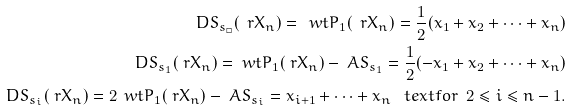<formula> <loc_0><loc_0><loc_500><loc_500>\ D S _ { s _ { \Box } } ( \ r X _ { n } ) = \ w t { P } _ { 1 } ( \ r X _ { n } ) = \frac { 1 } { 2 } ( x _ { 1 } + x _ { 2 } + \cdots + x _ { n } ) \\ \ D S _ { s _ { 1 } } ( \ r X _ { n } ) = \ w t { P } _ { 1 } ( \ r X _ { n } ) - \ A S _ { s _ { 1 } } = \frac { 1 } { 2 } ( - x _ { 1 } + x _ { 2 } + \cdots + x _ { n } ) \\ \ D S _ { s _ { i } } ( \ r X _ { n } ) = 2 \, \ w t { P } _ { 1 } ( \ r X _ { n } ) - \ A S _ { s _ { i } } = x _ { i + 1 } + \cdots + x _ { n } \ \ \ t e x t { f o r } \ \ 2 \leq i \leq n - 1 .</formula> 